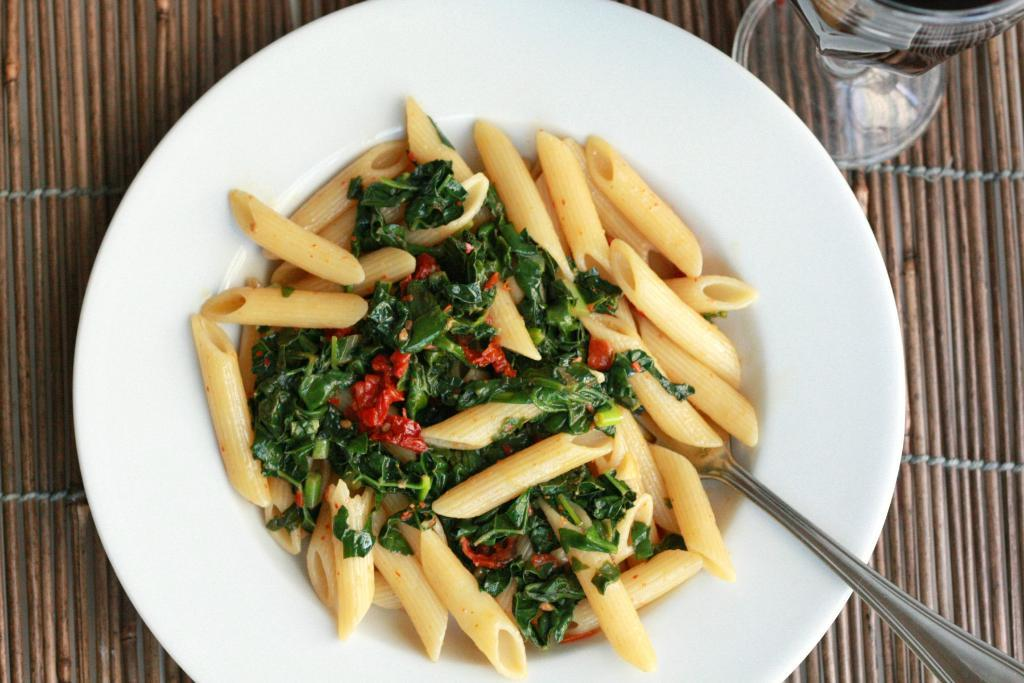What type of food is on the plate in the image? There is pasta on a plate in the image. What utensil is on the plate with the pasta? There is a fork on the plate in the image. What else is on the plate besides the pasta and fork? There is another food item on the plate in the image. What can be seen on the table in the image? There is a glass on the table in the image. How many toes are visible in the image? There are no toes visible in the image. What type of cherry is being used as a garnish on the plate? There is no cherry present on the plate or in the image. 